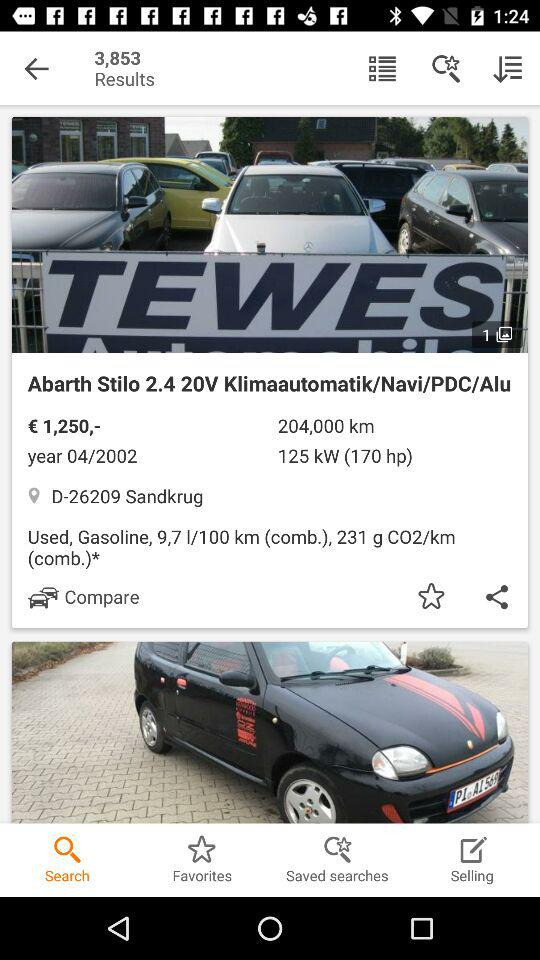How many results are there? There are 3,853 results. 